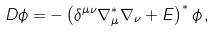Convert formula to latex. <formula><loc_0><loc_0><loc_500><loc_500>D \phi = - \left ( \delta ^ { \mu \nu } \nabla _ { \mu } ^ { * } \nabla _ { \nu } + E \right ) ^ { * } \phi \, ,</formula> 